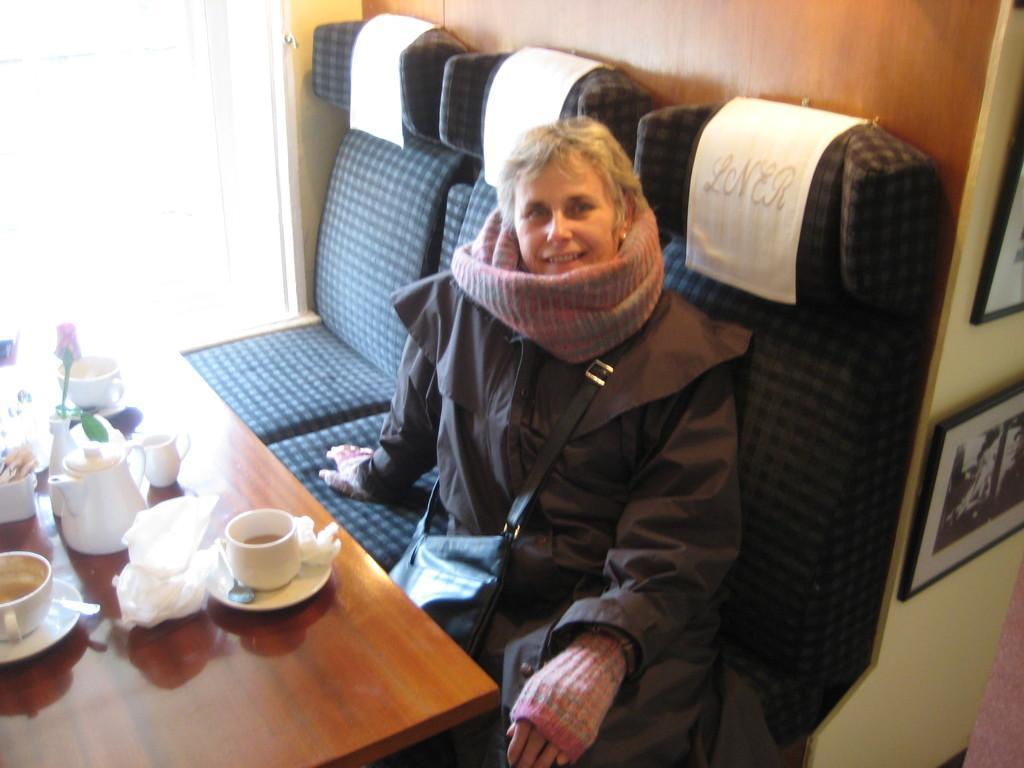Could you give a brief overview of what you see in this image? There are three seats on which one of them the woman is seated on it. She is wearing a black color bag and even a black color dress. She is even wearing gloves and shrug is covered around her neck. in front of her, we can see a table on which tea cup, saucer, tissue, jar, flower is placed on it. To the right of her, we can see a glass window from which can see the outside world. To the left of her, we can see photo frames which is placed on the wall. 